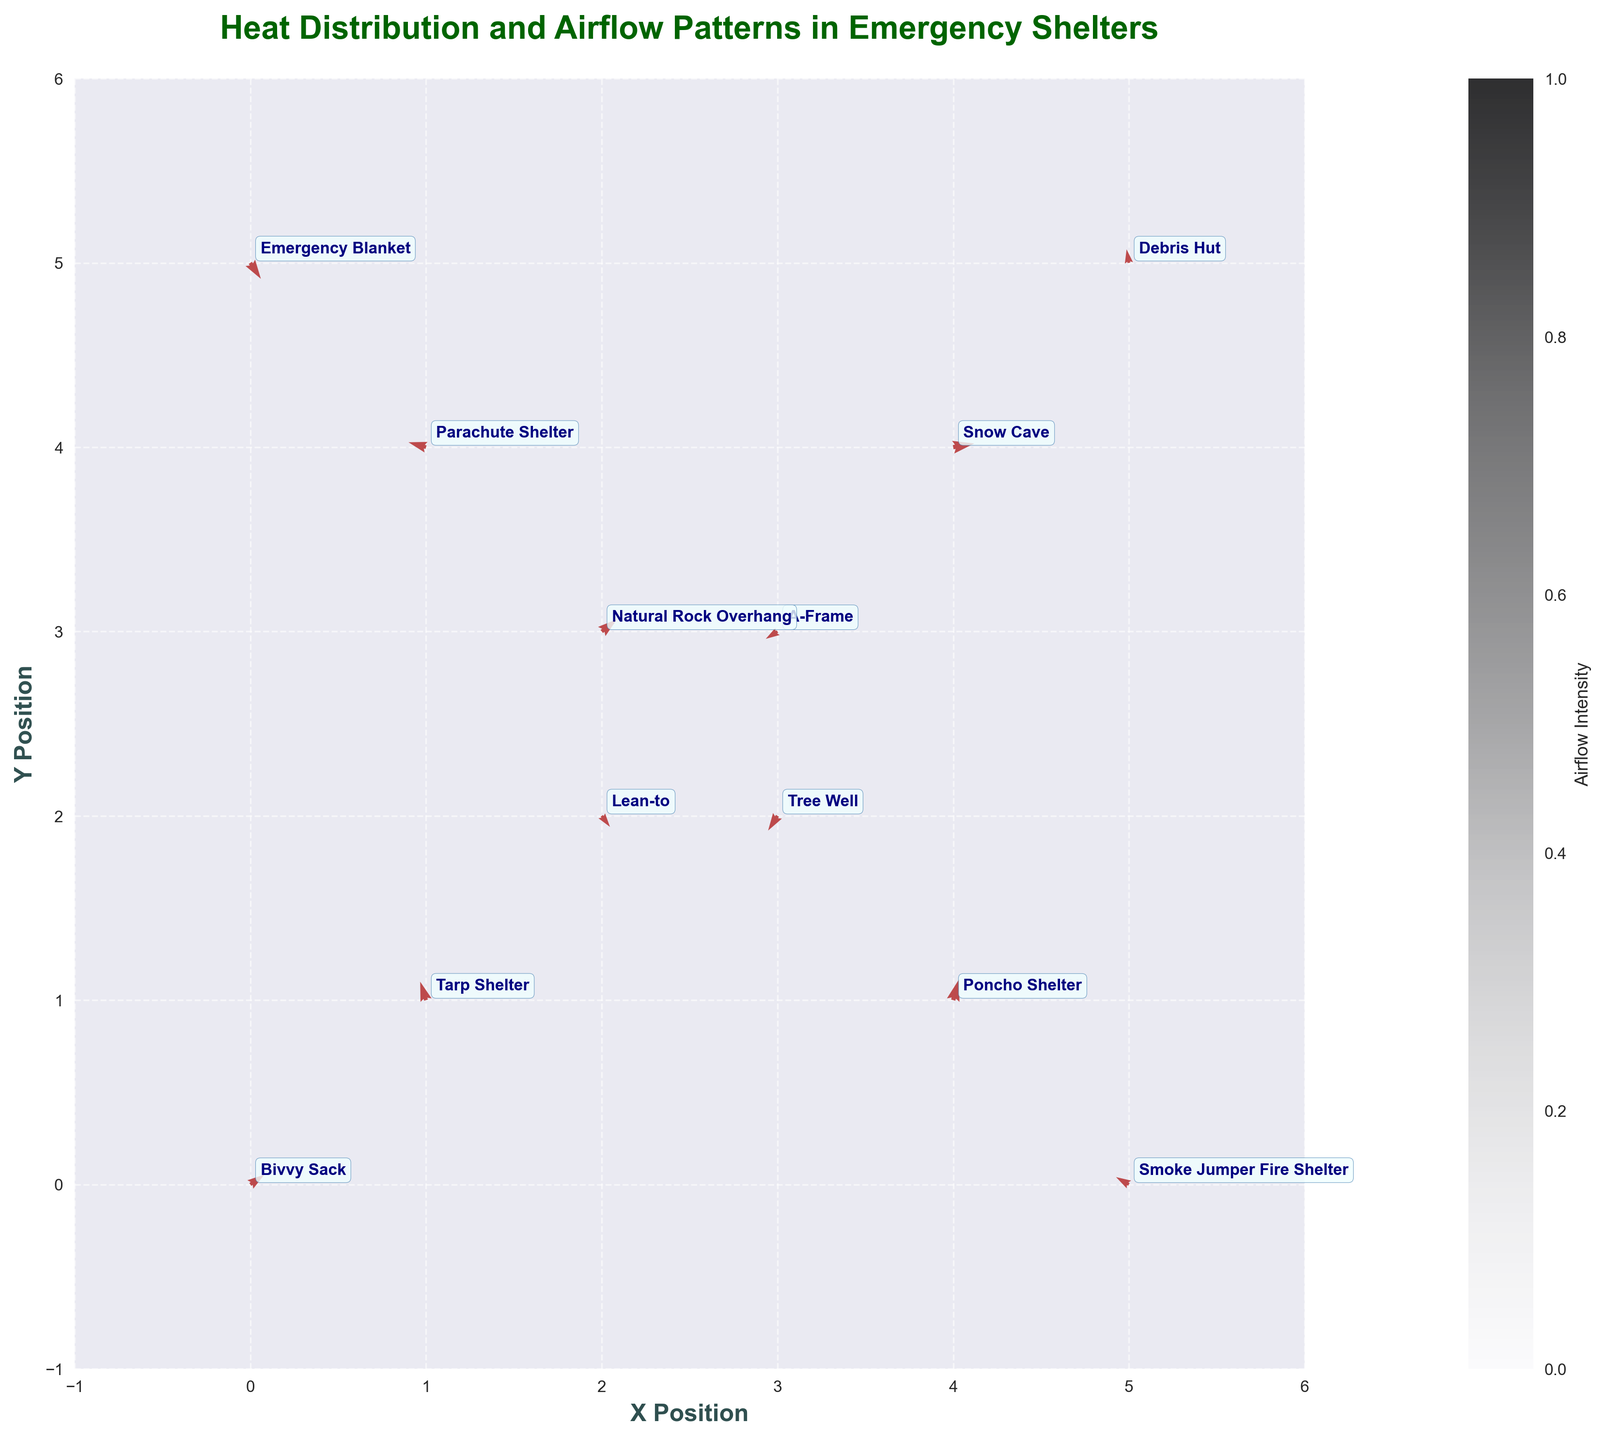How many different types of emergency shelters are shown in the figure? Count the number of different shelter types mentioned. Each shelter type appears once, yielding 12 unique types.
Answer: 12 What is the origin and direction of the airflow for the Bivvy Sack shelter? Locate the Bivvy Sack on the plot at coordinates (0, 0). The airflow vector is (1.2, 0.8), indicating it moves right and slightly up from the origin.
Answer: (0, 0), (1.2, 0.8) Which shelter shows the highest airflow intensity and what is its value? Analyze each vector's magnitude, calculated as sqrt(u^2 + v^2). The Snow Cave has the vector (1.8, 0.3), yielding the highest magnitude, approximately sqrt(1.8^2 + 0.3^2) ≈ 1.83.
Answer: Snow Cave, ~1.83 Which shelters show a negative x-component in their airflow vector? Identify vectors with negative 'u' values. These are Tarp Shelter, A-Frame, Parachute Shelter, Tree Well, and Smoke Jumper Fire Shelter.
Answer: Tarp Shelter, A-Frame, Parachute Shelter, Tree Well, Smoke Jumper Fire Shelter Between the Debris Hut and the Poncho Shelter, which one has greater airflow intensity and by how much? Calculate magnitudes for both vectors: Debris Hut (0.2^2 + 1.1^2)^0.5 ≈ 1.12, and Poncho Shelter (0.5^2 + 1.7^2)^0.5 ≈ 1.78. The Poncho Shelter has greater intensity by approximately 1.78 - 1.12 ≈ 0.66.
Answer: Poncho Shelter, ~0.66 What is the composite vector direction for the shelter at (3, 2) and at (2, 3)? Calculate each vector’s direction and magnitude: Tree Well (3,2) has a vector of (-0.8, -1.2), and Natural Rock Overhang (2,3) has a vector of (1.3, 1.0). Calculate directions using atan2(v, u).
Answer: Tree Well: south-west, Natural Rock Overhang: north-east If you overlay the vector from the Lean-to shelter onto the Parachute Shelter, what is the resulting vector? Add vectors from the Lean-to (0.7, -0.9) to Parachute Shelter (-1.5, 0.4): resulting vector (-0.8, -0.5).
Answer: (-0.8, -0.5) Which shelter's airflow vector points the farthest downward? Identify vectors with the most negative 'v' values. The Emergency Blanket has the vector (0.9, -1.3); -1.3 is the largest negative value.
Answer: Emergency Blanket 